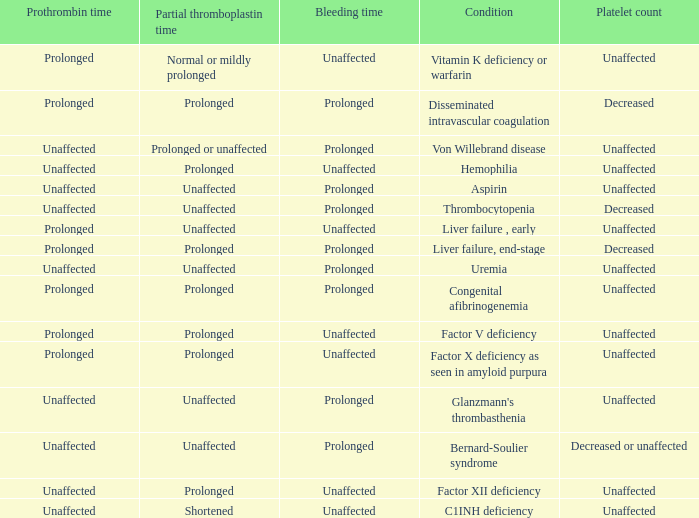Which Platelet count has a Condition of bernard-soulier syndrome? Decreased or unaffected. 